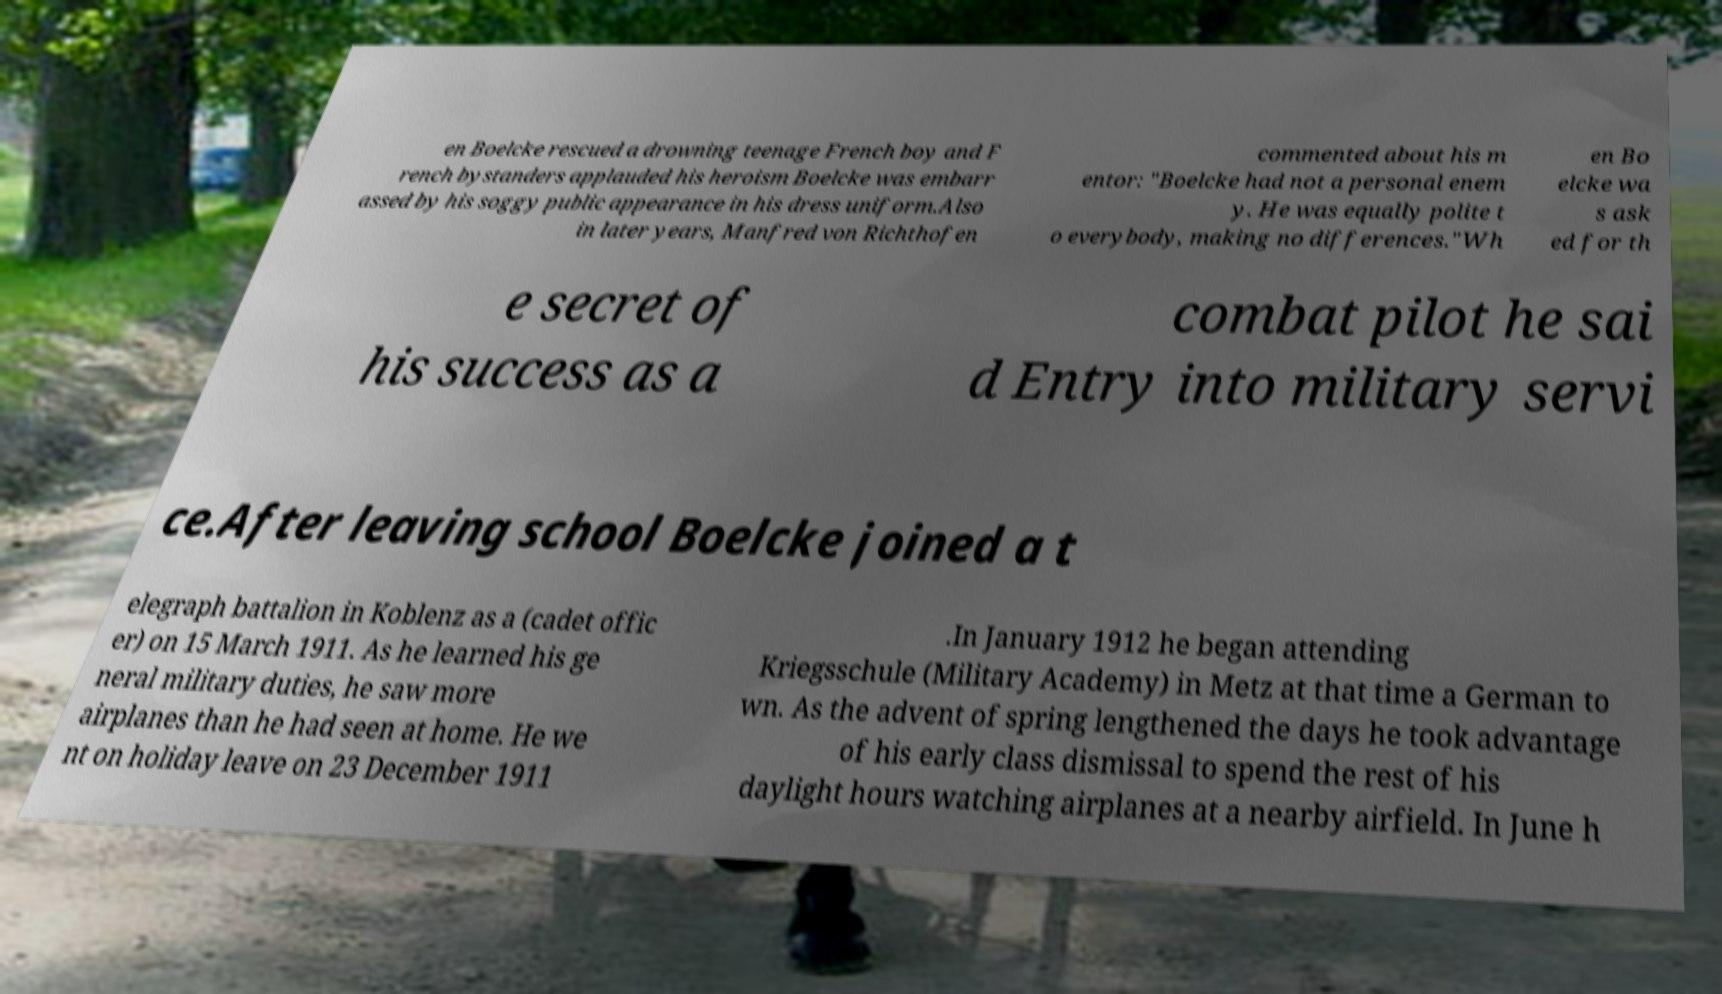There's text embedded in this image that I need extracted. Can you transcribe it verbatim? en Boelcke rescued a drowning teenage French boy and F rench bystanders applauded his heroism Boelcke was embarr assed by his soggy public appearance in his dress uniform.Also in later years, Manfred von Richthofen commented about his m entor: "Boelcke had not a personal enem y. He was equally polite t o everybody, making no differences."Wh en Bo elcke wa s ask ed for th e secret of his success as a combat pilot he sai d Entry into military servi ce.After leaving school Boelcke joined a t elegraph battalion in Koblenz as a (cadet offic er) on 15 March 1911. As he learned his ge neral military duties, he saw more airplanes than he had seen at home. He we nt on holiday leave on 23 December 1911 .In January 1912 he began attending Kriegsschule (Military Academy) in Metz at that time a German to wn. As the advent of spring lengthened the days he took advantage of his early class dismissal to spend the rest of his daylight hours watching airplanes at a nearby airfield. In June h 